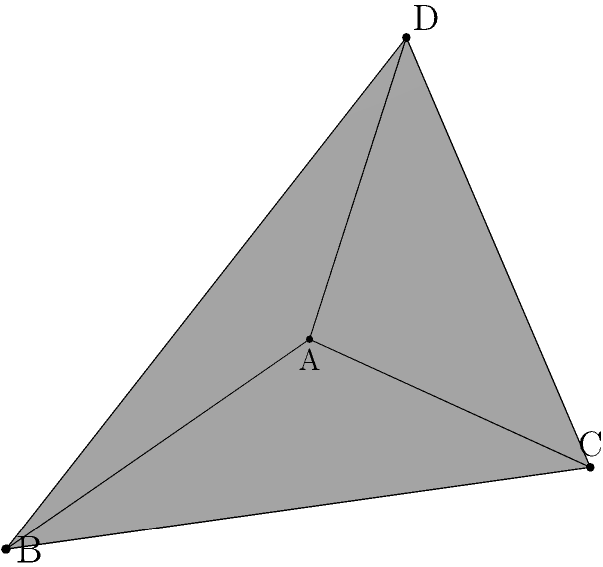A stand-up comedian is preparing a joke about geometry and decides to use a tetrahedron as a prop. The tetrahedron is defined by four points in 3D space: $A(0,0,0)$, $B(3,0,0)$, $C(1,2,0)$, and $D(1,1,2)$. Calculate the volume of this tetrahedron to determine how much laughter it can contain. Express your answer in cubic units. To find the volume of a tetrahedron given four non-coplanar points, we can use the following steps:

1) The volume of a tetrahedron is given by the formula:

   $$V = \frac{1}{6}|\det(\overrightarrow{AB}, \overrightarrow{AC}, \overrightarrow{AD})|$$

   where $\overrightarrow{AB}$, $\overrightarrow{AC}$, and $\overrightarrow{AD}$ are vectors.

2) Calculate the vectors:
   $\overrightarrow{AB} = B - A = (3,0,0) - (0,0,0) = (3,0,0)$
   $\overrightarrow{AC} = C - A = (1,2,0) - (0,0,0) = (1,2,0)$
   $\overrightarrow{AD} = D - A = (1,1,2) - (0,0,0) = (1,1,2)$

3) Form the determinant:

   $$\det = \begin{vmatrix} 
   3 & 1 & 1 \\
   0 & 2 & 1 \\
   0 & 0 & 2
   \end{vmatrix}$$

4) Calculate the determinant:
   $\det = 3 \cdot 2 \cdot 2 = 12$

5) Apply the volume formula:
   $$V = \frac{1}{6}|12| = 2$$

Therefore, the volume of the tetrahedron is 2 cubic units.
Answer: 2 cubic units 